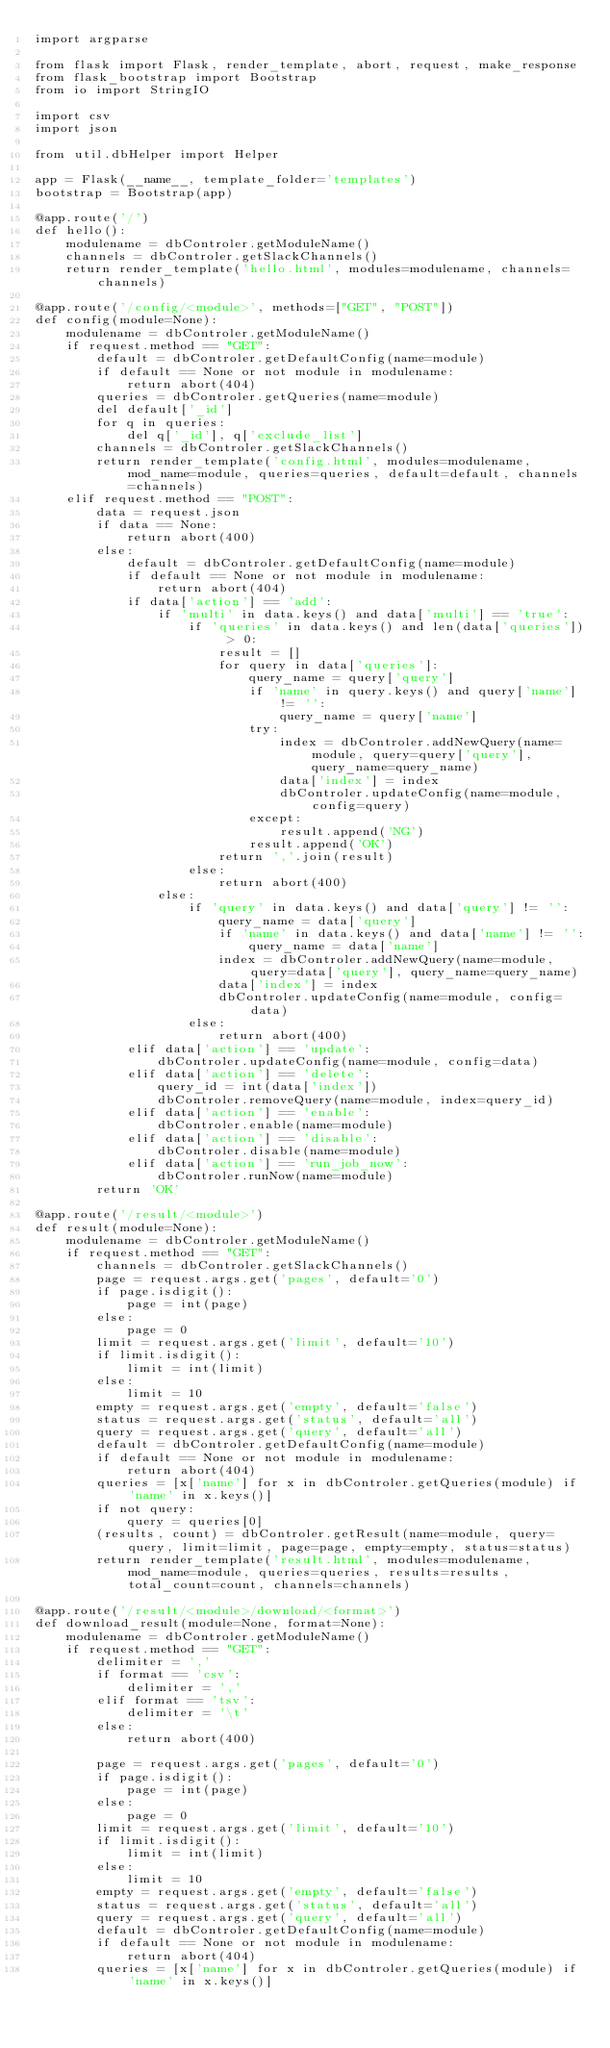<code> <loc_0><loc_0><loc_500><loc_500><_Python_>import argparse

from flask import Flask, render_template, abort, request, make_response
from flask_bootstrap import Bootstrap
from io import StringIO

import csv
import json

from util.dbHelper import Helper

app = Flask(__name__, template_folder='templates')
bootstrap = Bootstrap(app)

@app.route('/')
def hello():
    modulename = dbControler.getModuleName()
    channels = dbControler.getSlackChannels()
    return render_template('hello.html', modules=modulename, channels=channels)

@app.route('/config/<module>', methods=["GET", "POST"])
def config(module=None):
    modulename = dbControler.getModuleName()
    if request.method == "GET":
        default = dbControler.getDefaultConfig(name=module)
        if default == None or not module in modulename:
            return abort(404)
        queries = dbControler.getQueries(name=module)
        del default['_id']
        for q in queries:
            del q['_id'], q['exclude_list']
        channels = dbControler.getSlackChannels()
        return render_template('config.html', modules=modulename, mod_name=module, queries=queries, default=default, channels=channels)
    elif request.method == "POST":
        data = request.json
        if data == None:
            return abort(400)
        else:
            default = dbControler.getDefaultConfig(name=module)
            if default == None or not module in modulename:
                return abort(404)
            if data['action'] == 'add':
                if 'multi' in data.keys() and data['multi'] == 'true':
                    if 'queries' in data.keys() and len(data['queries']) > 0:
                        result = []
                        for query in data['queries']:
                            query_name = query['query']
                            if 'name' in query.keys() and query['name'] != '':
                                query_name = query['name']
                            try:
                                index = dbControler.addNewQuery(name=module, query=query['query'], query_name=query_name)
                                data['index'] = index
                                dbControler.updateConfig(name=module, config=query)
                            except:
                                result.append('NG')
                            result.append('OK')
                        return ','.join(result)
                    else:
                        return abort(400)
                else:
                    if 'query' in data.keys() and data['query'] != '':
                        query_name = data['query']
                        if 'name' in data.keys() and data['name'] != '':
                            query_name = data['name']
                        index = dbControler.addNewQuery(name=module, query=data['query'], query_name=query_name)
                        data['index'] = index
                        dbControler.updateConfig(name=module, config=data)
                    else:
                        return abort(400)
            elif data['action'] == 'update':
                dbControler.updateConfig(name=module, config=data)
            elif data['action'] == 'delete':
                query_id = int(data['index'])
                dbControler.removeQuery(name=module, index=query_id)
            elif data['action'] == 'enable':
                dbControler.enable(name=module)
            elif data['action'] == 'disable':
                dbControler.disable(name=module)
            elif data['action'] == 'run_job_now':
                dbControler.runNow(name=module)
        return 'OK'

@app.route('/result/<module>')
def result(module=None):
    modulename = dbControler.getModuleName()
    if request.method == "GET":
        channels = dbControler.getSlackChannels()
        page = request.args.get('pages', default='0')
        if page.isdigit():
            page = int(page)
        else:
            page = 0
        limit = request.args.get('limit', default='10')
        if limit.isdigit():
            limit = int(limit)
        else:
            limit = 10
        empty = request.args.get('empty', default='false')
        status = request.args.get('status', default='all')
        query = request.args.get('query', default='all')
        default = dbControler.getDefaultConfig(name=module)
        if default == None or not module in modulename:
            return abort(404)
        queries = [x['name'] for x in dbControler.getQueries(module) if 'name' in x.keys()]
        if not query:
            query = queries[0]
        (results, count) = dbControler.getResult(name=module, query=query, limit=limit, page=page, empty=empty, status=status)
        return render_template('result.html', modules=modulename, mod_name=module, queries=queries, results=results, total_count=count, channels=channels)

@app.route('/result/<module>/download/<format>')
def download_result(module=None, format=None):
    modulename = dbControler.getModuleName()
    if request.method == "GET":
        delimiter = ','
        if format == 'csv':
            delimiter = ','
        elif format == 'tsv':
            delimiter = '\t'
        else:
            return abort(400)

        page = request.args.get('pages', default='0')
        if page.isdigit():
            page = int(page)
        else:
            page = 0
        limit = request.args.get('limit', default='10')
        if limit.isdigit():
            limit = int(limit)
        else:
            limit = 10
        empty = request.args.get('empty', default='false')
        status = request.args.get('status', default='all')
        query = request.args.get('query', default='all')
        default = dbControler.getDefaultConfig(name=module)
        if default == None or not module in modulename:
            return abort(404)
        queries = [x['name'] for x in dbControler.getQueries(module) if 'name' in x.keys()]</code> 